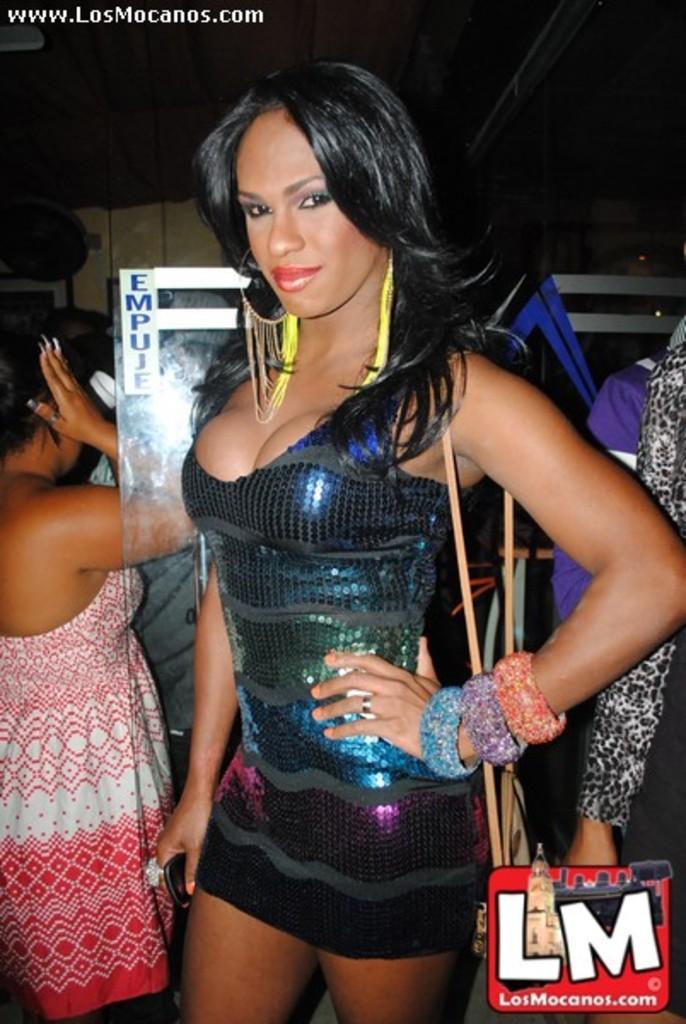Could you give a brief overview of what you see in this image? In this image we can see a woman standing and posing for a photo and there are few people in the background and we can see a glass object and there is some text on it and we can see some text on the image. 